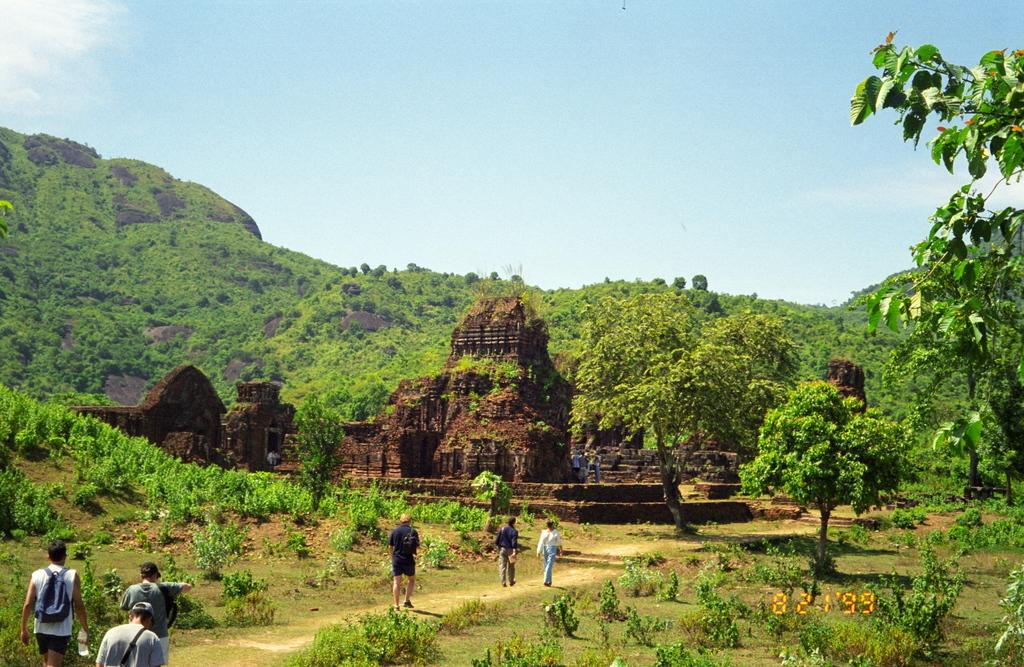What are the people in the image doing? The people in the image are walking on the ground. What type of vegetation can be seen in the image? Trees are present in the image. What type of pathway is visible in the image? There is a road in the image. What type of geographical feature can be seen in the distance? Mountains are visible in the image. What is visible in the background of the image? The sky is visible in the background of the image. What type of farm animals can be seen grazing in the image? There are no farm animals present in the image. What color is the ear of the person walking on the ground in the image? The image does not show the ears of the people walking on the ground, so it cannot be determined what color they are. 